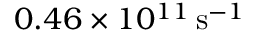<formula> <loc_0><loc_0><loc_500><loc_500>0 . 4 6 \times 1 0 ^ { 1 1 } \, s ^ { - 1 }</formula> 